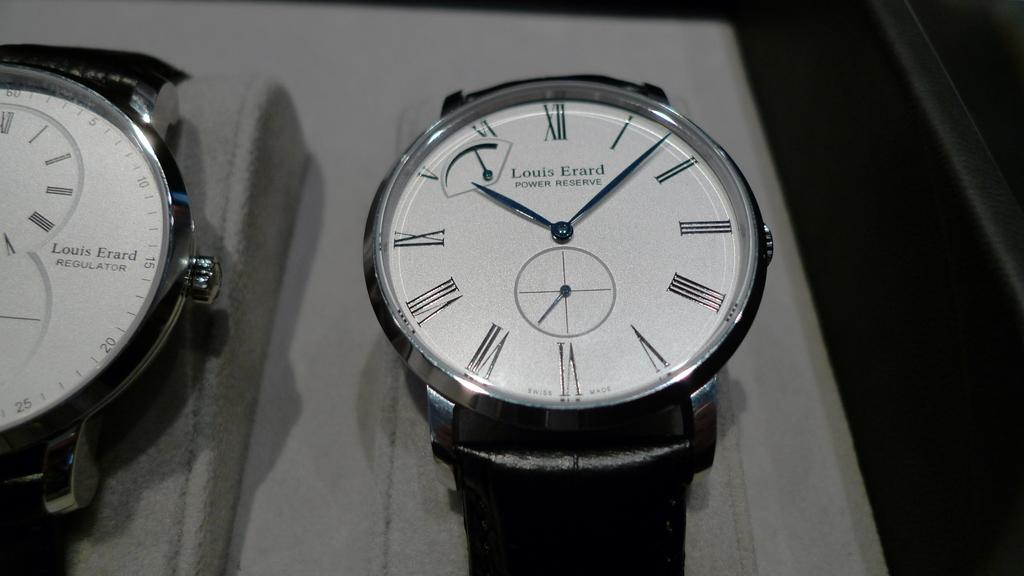Provide a one-sentence caption for the provided image. The black watch with a white dial is a Louis Erard Power Reserve. 